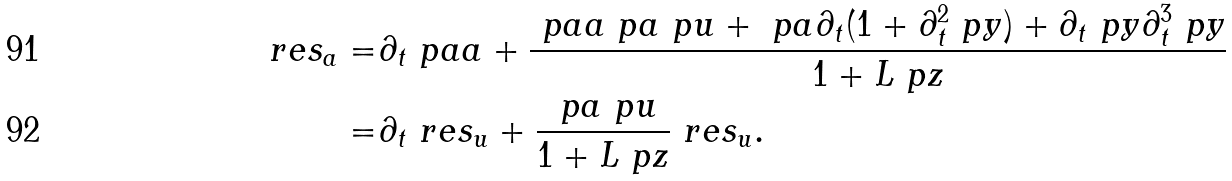Convert formula to latex. <formula><loc_0><loc_0><loc_500><loc_500>\ r e s _ { a } = & \partial _ { t } \ p a a + \frac { \ p a a \ p a \ p u + \ p a \partial _ { t } ( 1 + \partial _ { t } ^ { 2 } \ p y ) + \partial _ { t } \ p y \partial _ { t } ^ { 3 } \ p y } { 1 + L \ p z } \\ = & \partial _ { t } \ r e s _ { u } + \frac { \ p a \ p u } { 1 + L \ p z } \ r e s _ { u } .</formula> 